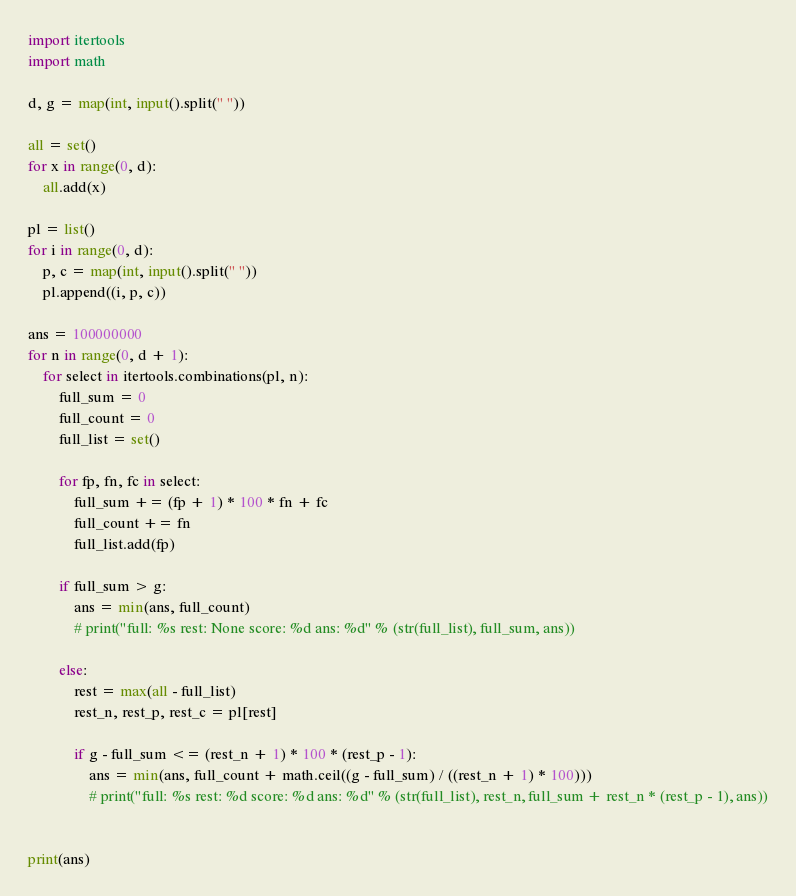Convert code to text. <code><loc_0><loc_0><loc_500><loc_500><_Python_>import itertools
import math

d, g = map(int, input().split(" "))

all = set()
for x in range(0, d):
    all.add(x)

pl = list()
for i in range(0, d):
    p, c = map(int, input().split(" "))
    pl.append((i, p, c))

ans = 100000000
for n in range(0, d + 1):
    for select in itertools.combinations(pl, n):
        full_sum = 0
        full_count = 0
        full_list = set()

        for fp, fn, fc in select:
            full_sum += (fp + 1) * 100 * fn + fc
            full_count += fn
            full_list.add(fp)
        
        if full_sum > g:
            ans = min(ans, full_count)
            # print("full: %s rest: None score: %d ans: %d" % (str(full_list), full_sum, ans))

        else:
            rest = max(all - full_list)
            rest_n, rest_p, rest_c = pl[rest]

            if g - full_sum <= (rest_n + 1) * 100 * (rest_p - 1):
                ans = min(ans, full_count + math.ceil((g - full_sum) / ((rest_n + 1) * 100)))
                # print("full: %s rest: %d score: %d ans: %d" % (str(full_list), rest_n, full_sum + rest_n * (rest_p - 1), ans))
        

print(ans)

</code> 